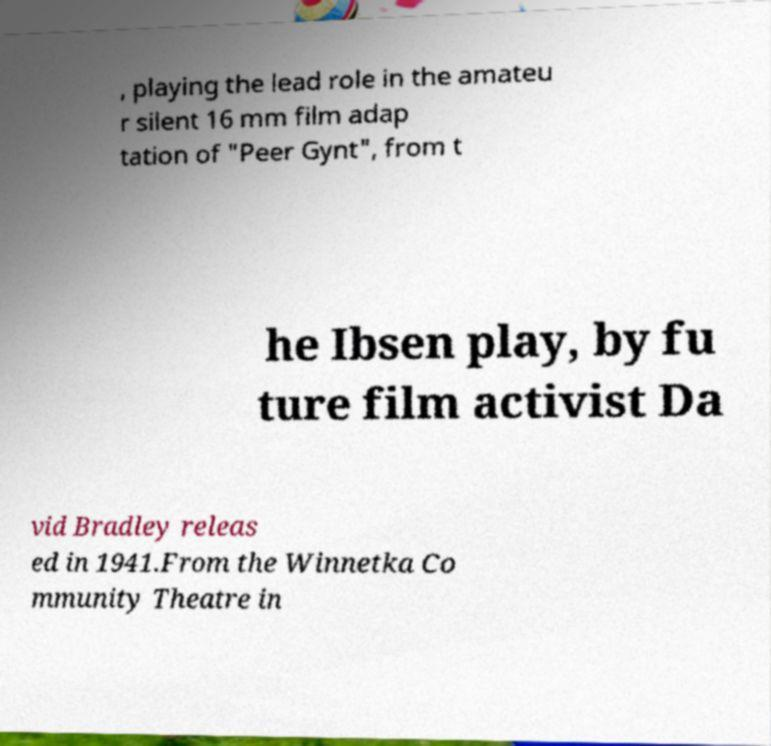Could you assist in decoding the text presented in this image and type it out clearly? , playing the lead role in the amateu r silent 16 mm film adap tation of "Peer Gynt", from t he Ibsen play, by fu ture film activist Da vid Bradley releas ed in 1941.From the Winnetka Co mmunity Theatre in 